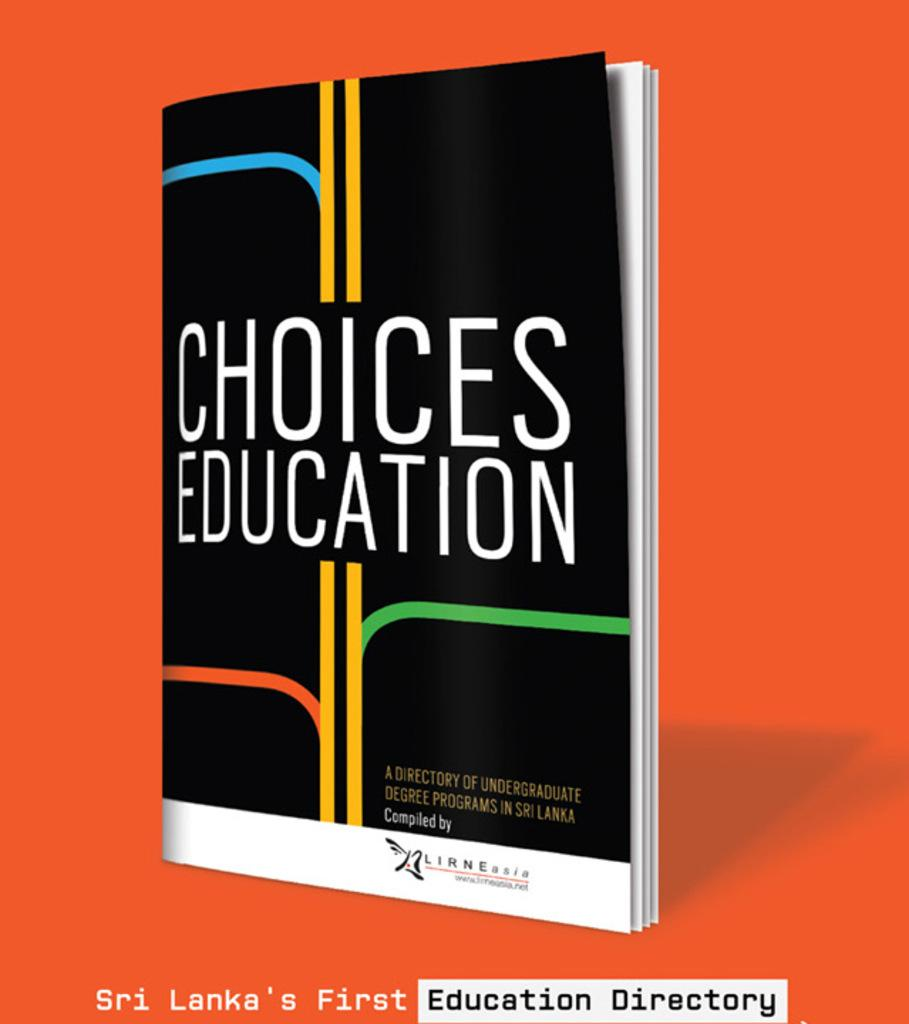<image>
Create a compact narrative representing the image presented. A book of undergraduate degree programs in Sir Lanka called Choices Education. 